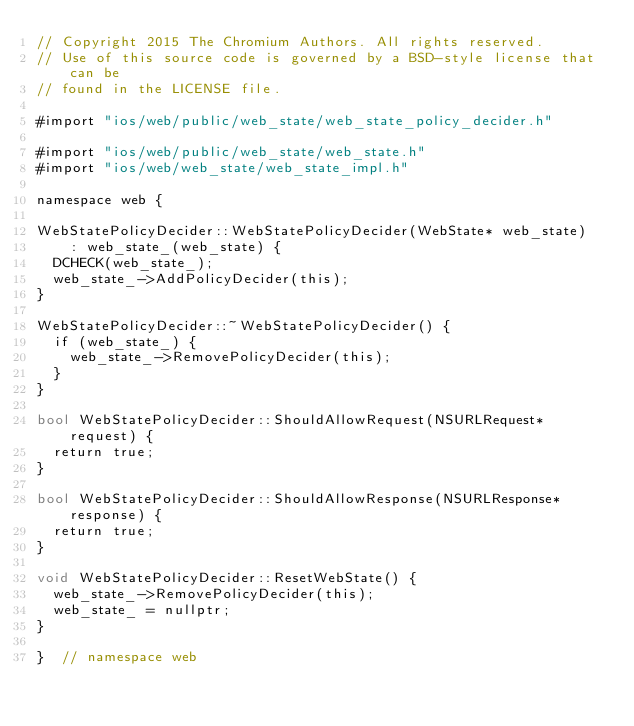<code> <loc_0><loc_0><loc_500><loc_500><_ObjectiveC_>// Copyright 2015 The Chromium Authors. All rights reserved.
// Use of this source code is governed by a BSD-style license that can be
// found in the LICENSE file.

#import "ios/web/public/web_state/web_state_policy_decider.h"

#import "ios/web/public/web_state/web_state.h"
#import "ios/web/web_state/web_state_impl.h"

namespace web {

WebStatePolicyDecider::WebStatePolicyDecider(WebState* web_state)
    : web_state_(web_state) {
  DCHECK(web_state_);
  web_state_->AddPolicyDecider(this);
}

WebStatePolicyDecider::~WebStatePolicyDecider() {
  if (web_state_) {
    web_state_->RemovePolicyDecider(this);
  }
}

bool WebStatePolicyDecider::ShouldAllowRequest(NSURLRequest* request) {
  return true;
}

bool WebStatePolicyDecider::ShouldAllowResponse(NSURLResponse* response) {
  return true;
}

void WebStatePolicyDecider::ResetWebState() {
  web_state_->RemovePolicyDecider(this);
  web_state_ = nullptr;
}

}  // namespace web
</code> 